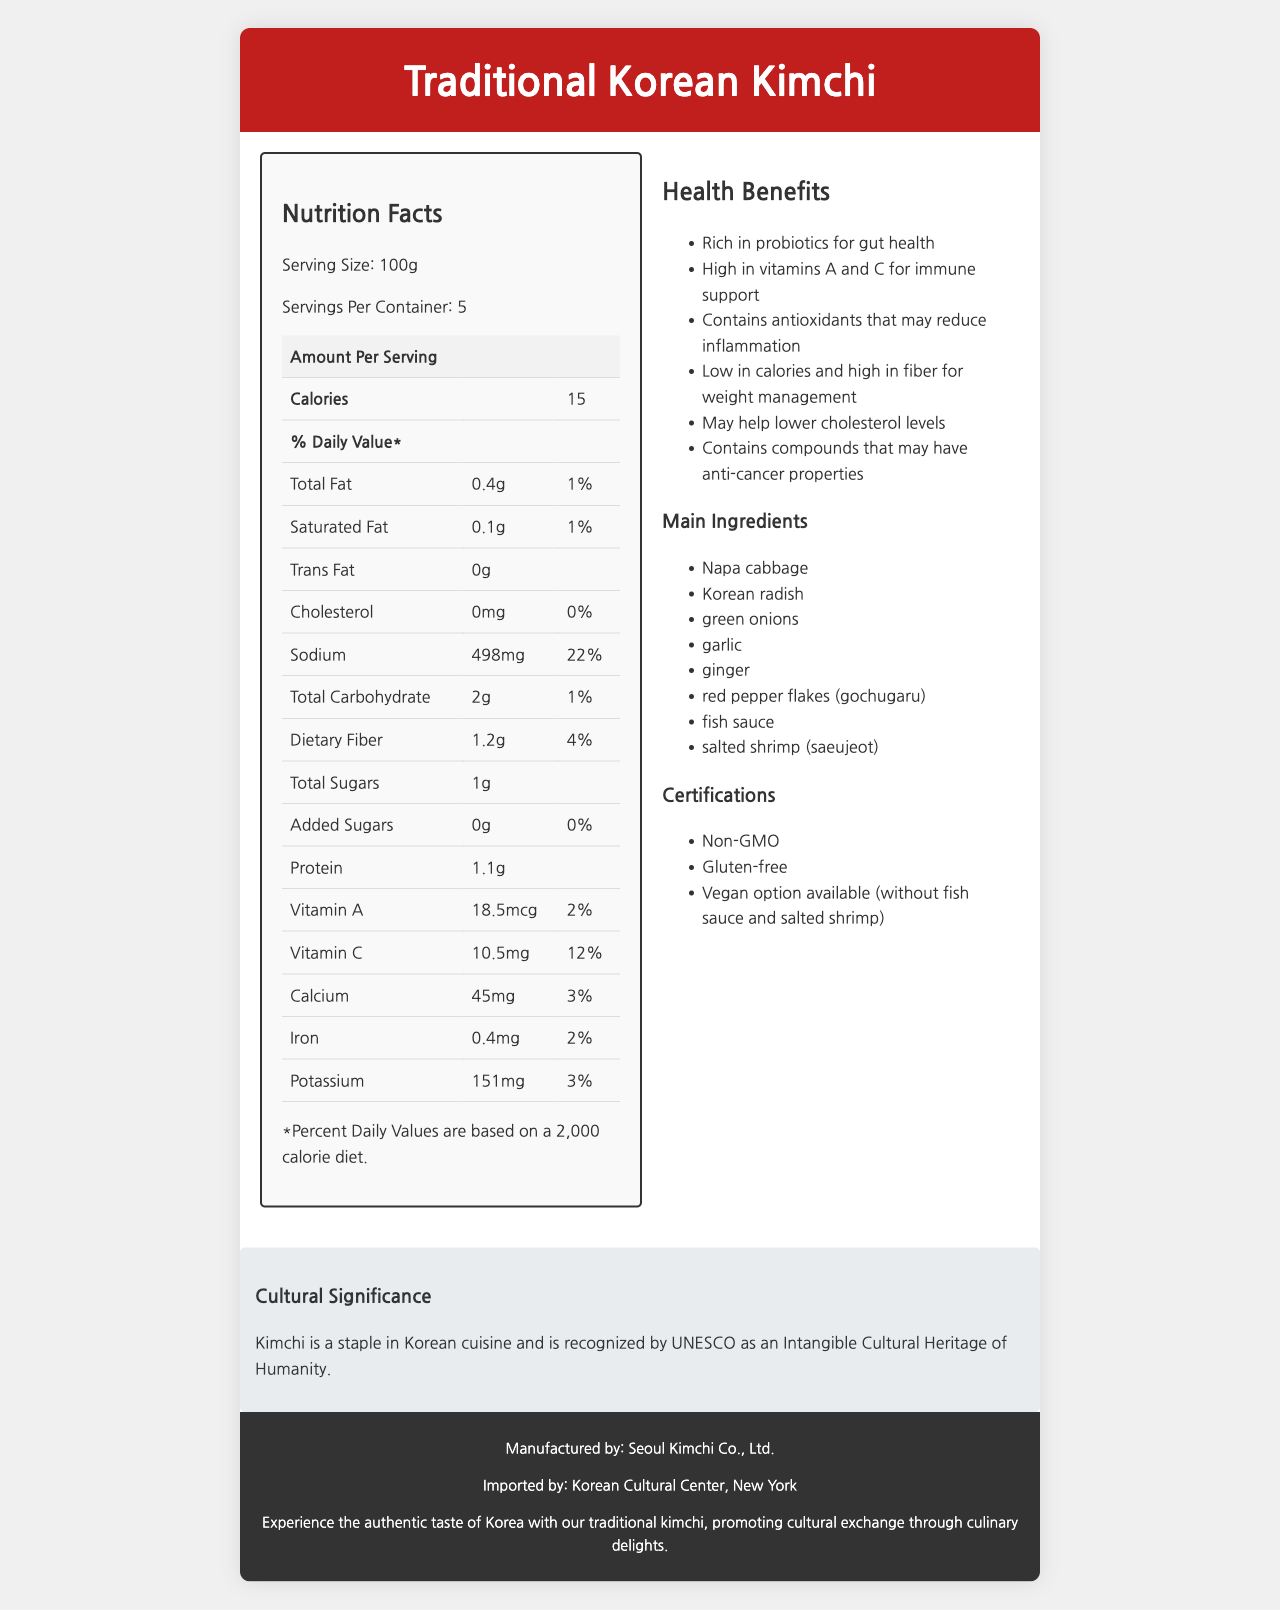what is the serving size of Traditional Korean Kimchi? The serving size is listed as 100g in the Nutrition Facts section.
Answer: 100g how many calories are in one serving of kimchi? The calories per serving are specified as 15 in the document.
Answer: 15 what percentage of Daily Value is the amount of sodium per serving? The sodium content per serving has a Daily Value of 22%, as shown in the Nutrition Facts.
Answer: 22% which ingredient in traditional kimchi might someone with seafood allergies want to avoid? The allergen info states that the product contains fish and shellfish, and the ingredients list includes fish sauce and salted shrimp.
Answer: Fish sauce and salted shrimp (saeujeot) what is one health benefit of consuming traditional Korean kimchi? One of the listed health benefits is that kimchi is rich in probiotics, which are good for gut health.
Answer: Rich in probiotics for gut health what are the main vitamins found in traditional Korean kimchi? The document shows that kimchi contains Vitamin A (18.5mcg) and Vitamin C (10.5mg).
Answer: Vitamin A and Vitamin C how long should kimchi be fermented at room temperature according to the document? The preparation method instructs fermentation for 3-5 days at room temperature.
Answer: 3-5 days what is the traditional Korean ingredient used for the spiciness of kimchi? The ingredient list includes red pepper flakes (gochugaru) as a source of spiciness.
Answer: Red pepper flakes (gochugaru) what certifications does the traditional Korean kimchi have? A. Organic B. Non-GMO C. Gluten-free D. Halal E. Vegan option available The kimchi is certified as Non-GMO, Gluten-free, and offers a Vegan option available (without fish sauce and salted shrimp).
Answer: B, C, E what percentage of daily value does vitamin C provide in one serving of kimchi? A. 2% B. 12% C. 20% D. 5% The daily value percentage of Vitamin C in one serving is listed as 12%.
Answer: B is the traditional Korean kimchi product gluten-free? According to the certifications listed, the product is gluten-free.
Answer: Yes does the product contain added sugars? The document states that the amount of added sugars is 0g.
Answer: No summarize the main idea of the document. The document provides the nutrition facts, ingredients, health benefits, cultural significance, and certifications of Traditional Korean Kimchi, emphasizing its health benefits and cultural relevance.
Answer: Experience the authentic taste of Korea with Traditional Korean Kimchi, a low-calorie food rich in probiotics and vitamins, promoting health and cultural exchange. what is the exact address of the manufacturer of this kimchi? The document specifies the address only as "123 Jongno-gu, Seoul, South Korea" but does not provide the exact street address.
Answer: Not enough information 